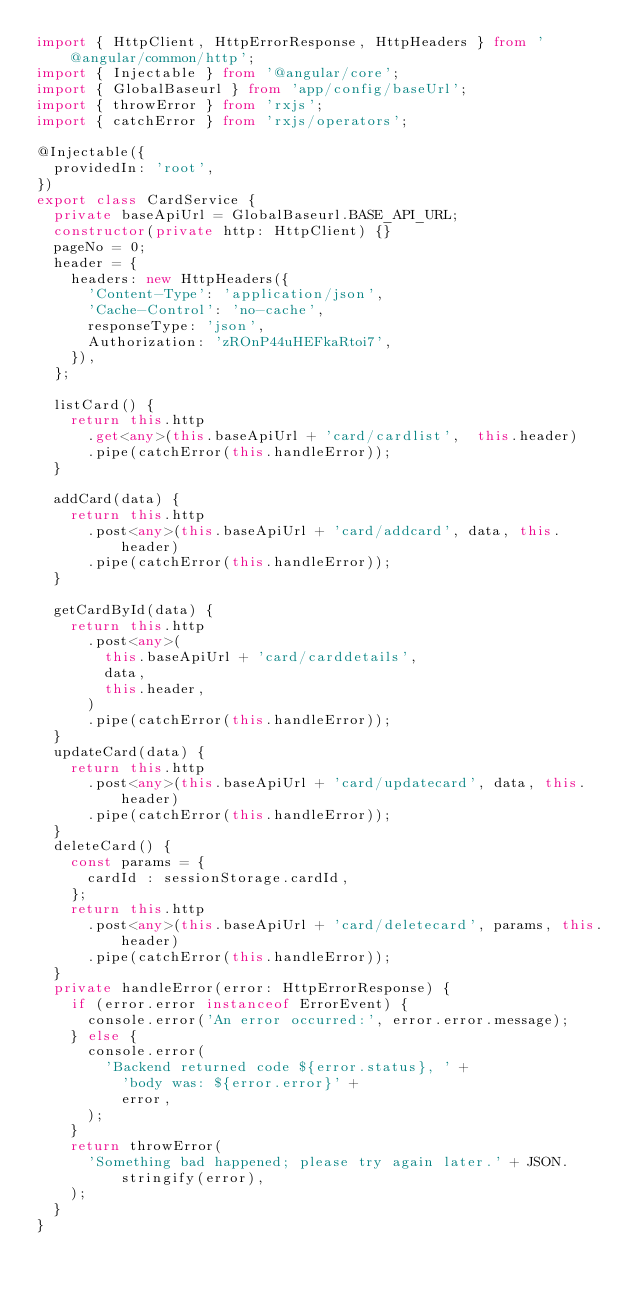Convert code to text. <code><loc_0><loc_0><loc_500><loc_500><_TypeScript_>import { HttpClient, HttpErrorResponse, HttpHeaders } from '@angular/common/http';
import { Injectable } from '@angular/core';
import { GlobalBaseurl } from 'app/config/baseUrl';
import { throwError } from 'rxjs';
import { catchError } from 'rxjs/operators';

@Injectable({
  providedIn: 'root',
})
export class CardService {
  private baseApiUrl = GlobalBaseurl.BASE_API_URL;
  constructor(private http: HttpClient) {}
  pageNo = 0;
  header = {
    headers: new HttpHeaders({
      'Content-Type': 'application/json',
      'Cache-Control': 'no-cache',
      responseType: 'json',
      Authorization: 'zROnP44uHEFkaRtoi7',
    }),
  };

  listCard() {
    return this.http
      .get<any>(this.baseApiUrl + 'card/cardlist',  this.header)
      .pipe(catchError(this.handleError));
  }

  addCard(data) {
    return this.http
      .post<any>(this.baseApiUrl + 'card/addcard', data, this.header)
      .pipe(catchError(this.handleError));
  }

  getCardById(data) {
    return this.http
      .post<any>(
        this.baseApiUrl + 'card/carddetails',
        data,
        this.header,
      )
      .pipe(catchError(this.handleError));
  }
  updateCard(data) {
    return this.http
      .post<any>(this.baseApiUrl + 'card/updatecard', data, this.header)
      .pipe(catchError(this.handleError));
  }
  deleteCard() {
    const params = {
      cardId : sessionStorage.cardId,
    };
    return this.http
      .post<any>(this.baseApiUrl + 'card/deletecard', params, this.header)
      .pipe(catchError(this.handleError));
  }
  private handleError(error: HttpErrorResponse) {
    if (error.error instanceof ErrorEvent) {
      console.error('An error occurred:', error.error.message);
    } else {
      console.error(
        'Backend returned code ${error.status}, ' +
          'body was: ${error.error}' +
          error,
      );
    }
    return throwError(
      'Something bad happened; please try again later.' + JSON.stringify(error),
    );
  }
}
</code> 